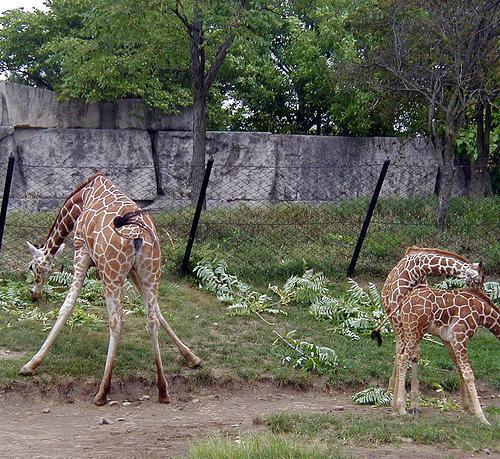How many animals are there?
Give a very brief answer. 2. How many giraffes are there?
Give a very brief answer. 3. 